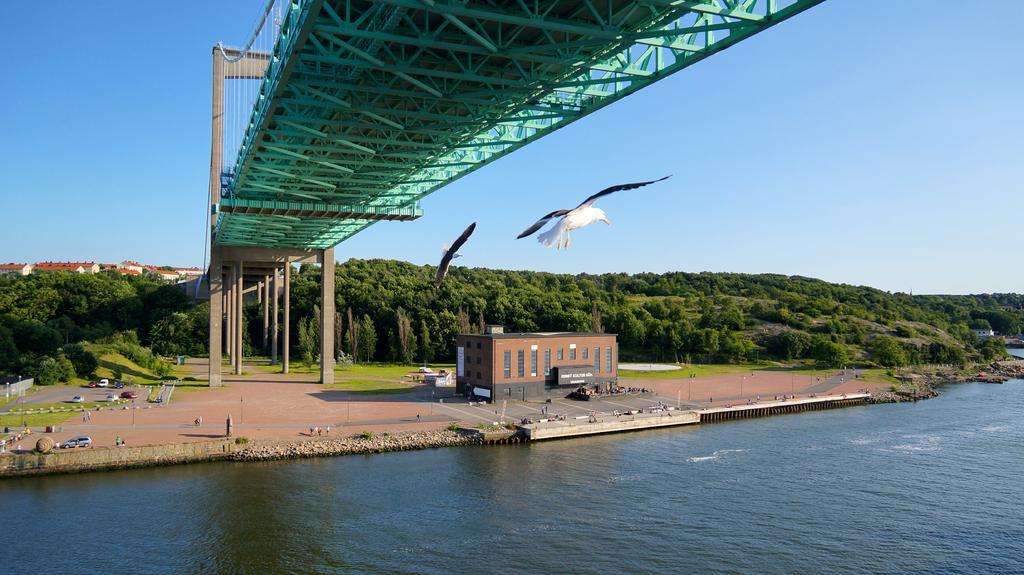How would you summarize this image in a sentence or two? In this image I can see in the middle two birds are flying, at the top it is the bridge, at the bottom it looks like a river and there is a house at here, at the back side there are trees. At the top it is the sky. 